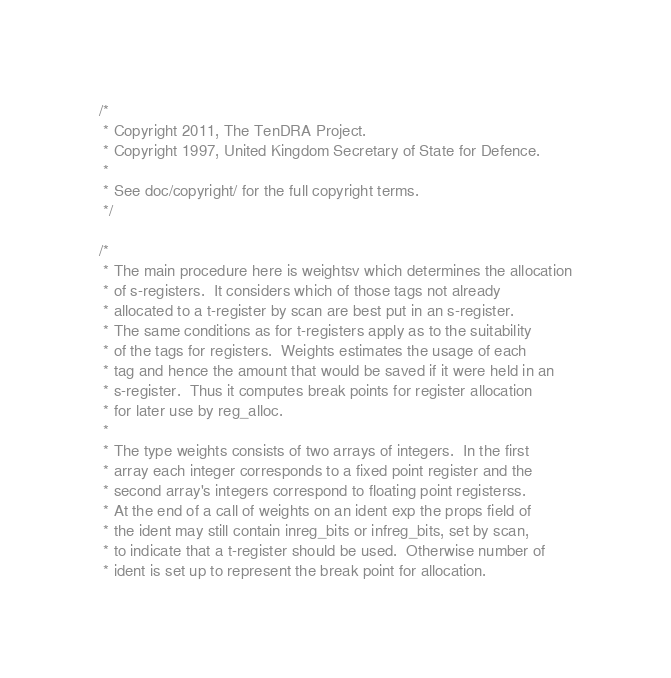<code> <loc_0><loc_0><loc_500><loc_500><_C_>/*
 * Copyright 2011, The TenDRA Project.
 * Copyright 1997, United Kingdom Secretary of State for Defence.
 *
 * See doc/copyright/ for the full copyright terms.
 */

/*
 * The main procedure here is weightsv which determines the allocation
 * of s-registers.  It considers which of those tags not already
 * allocated to a t-register by scan are best put in an s-register.
 * The same conditions as for t-registers apply as to the suitability
 * of the tags for registers.  Weights estimates the usage of each
 * tag and hence the amount that would be saved if it were held in an
 * s-register.  Thus it computes break points for register allocation
 * for later use by reg_alloc.
 *
 * The type weights consists of two arrays of integers.  In the first
 * array each integer corresponds to a fixed point register and the
 * second array's integers correspond to floating point registerss.
 * At the end of a call of weights on an ident exp the props field of
 * the ident may still contain inreg_bits or infreg_bits, set by scan,
 * to indicate that a t-register should be used.  Otherwise number of
 * ident is set up to represent the break point for allocation.</code> 